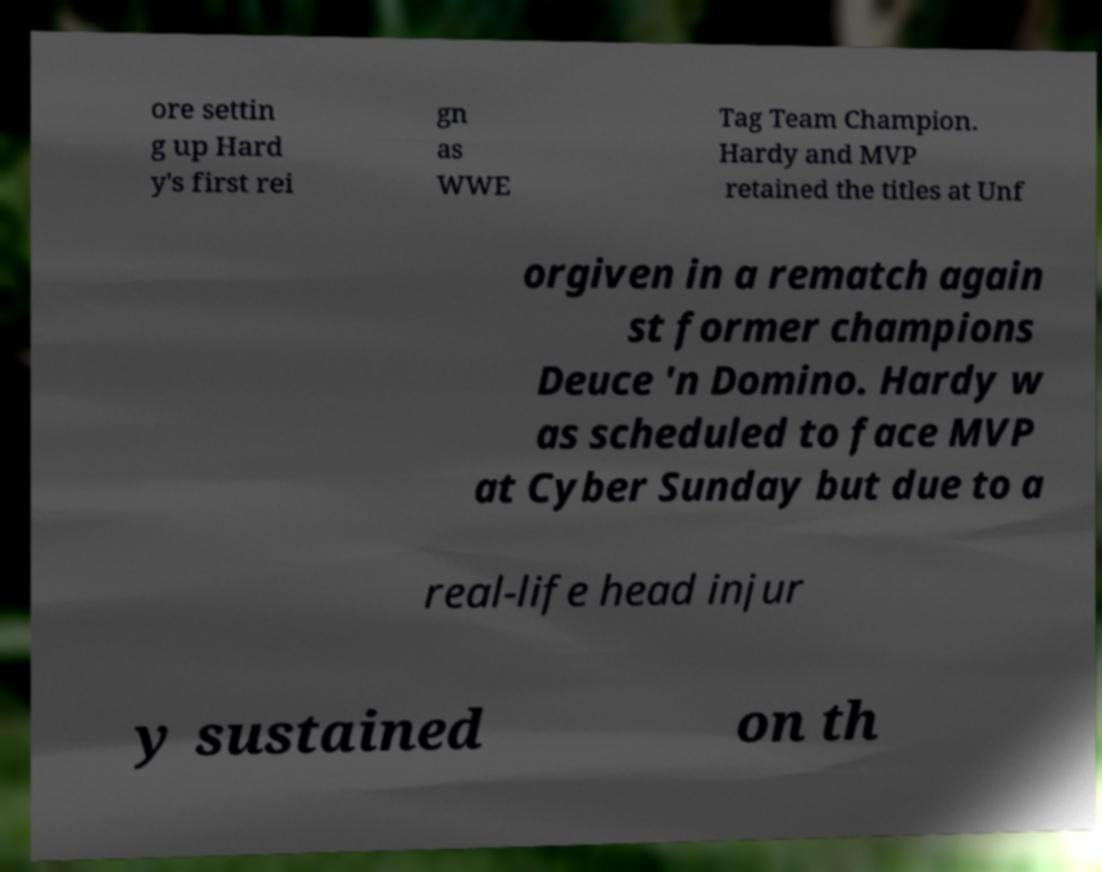For documentation purposes, I need the text within this image transcribed. Could you provide that? ore settin g up Hard y's first rei gn as WWE Tag Team Champion. Hardy and MVP retained the titles at Unf orgiven in a rematch again st former champions Deuce 'n Domino. Hardy w as scheduled to face MVP at Cyber Sunday but due to a real-life head injur y sustained on th 